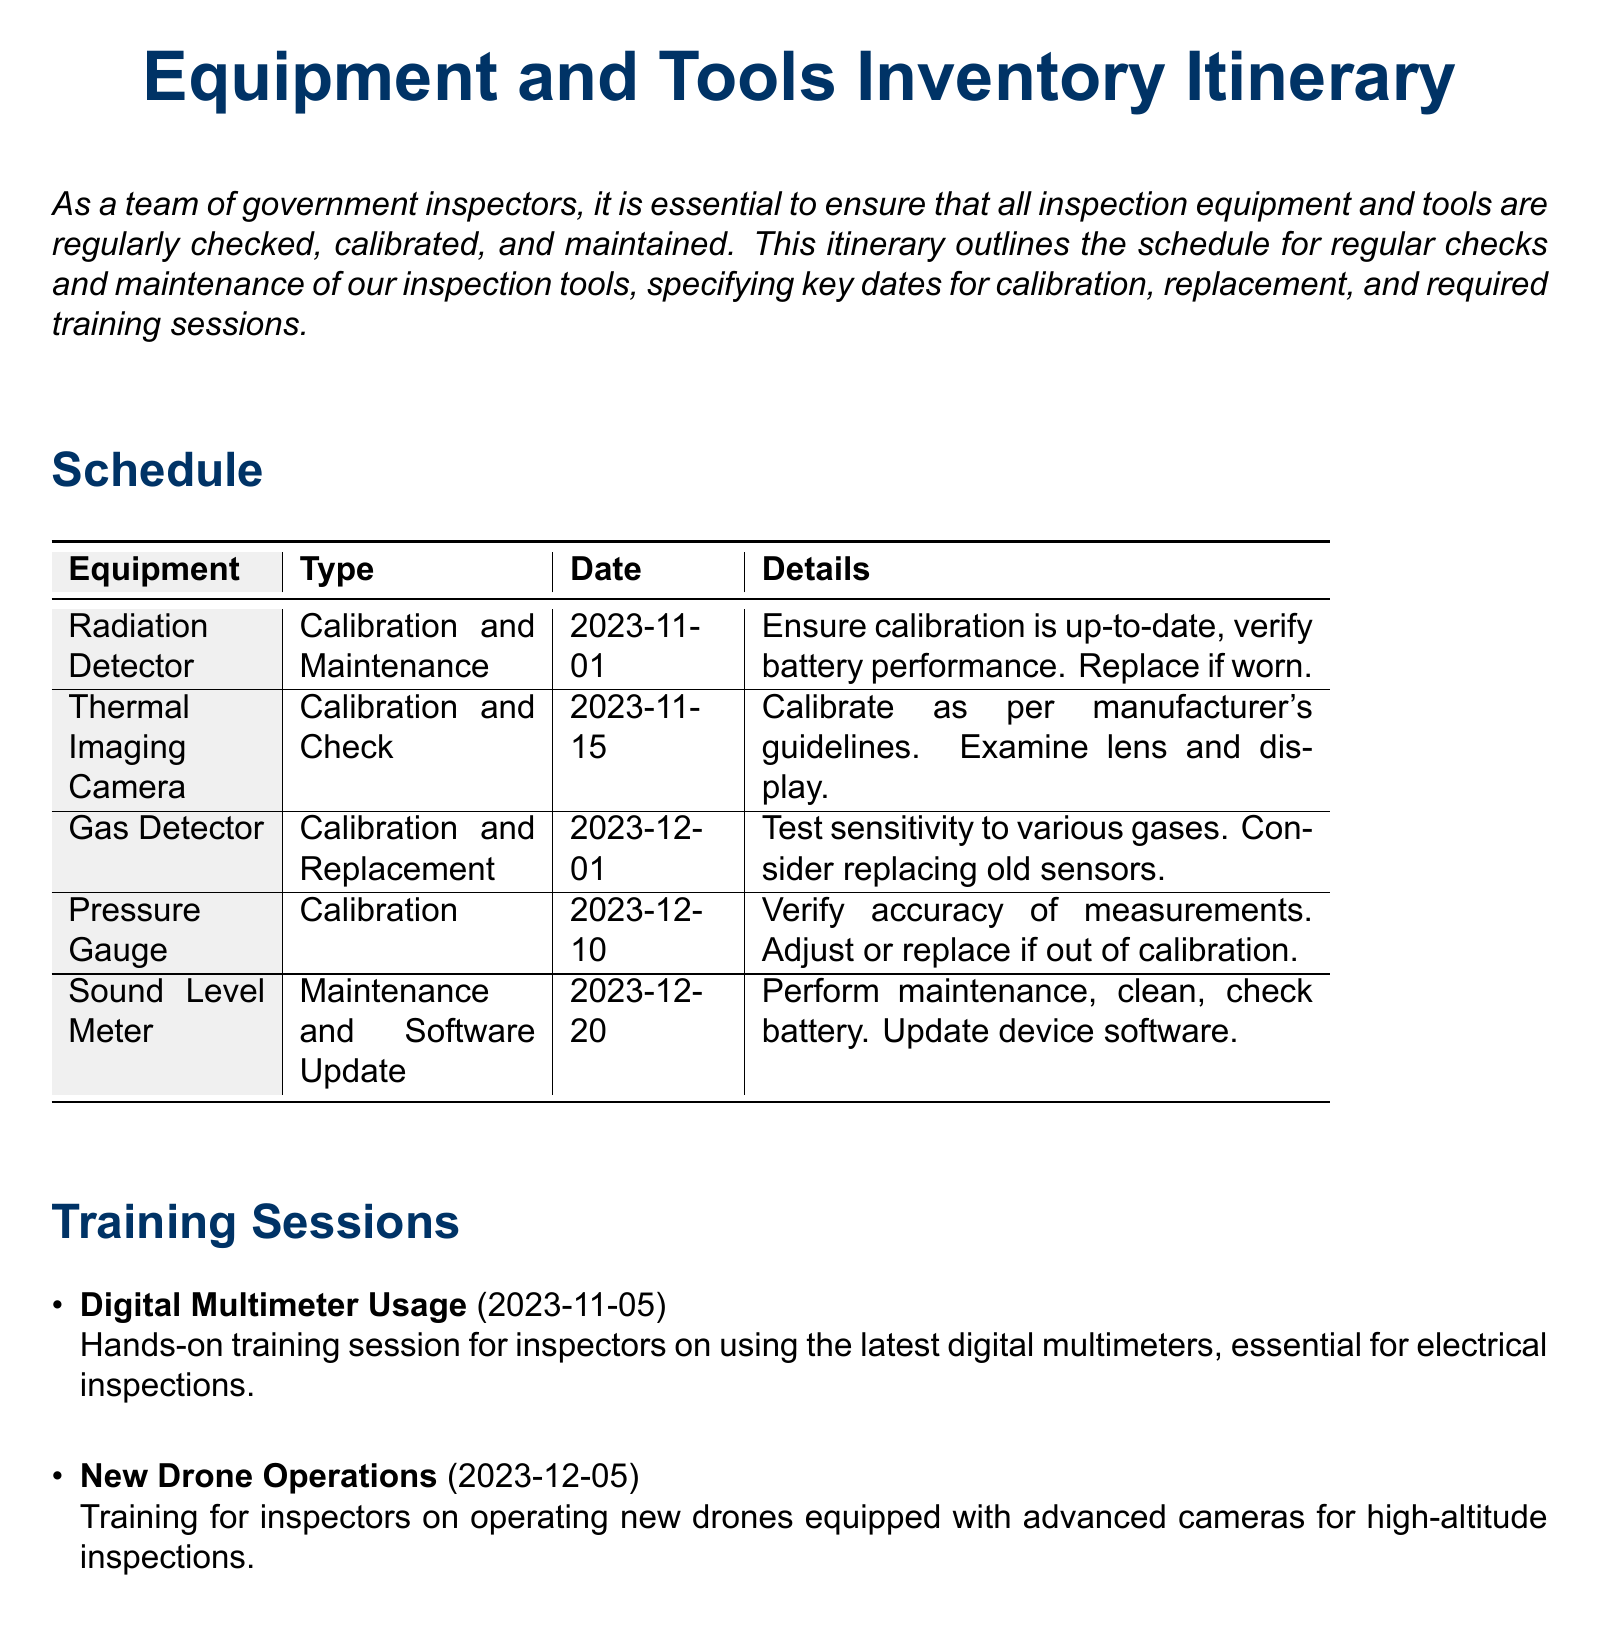What is the date for calibrating the Radiation Detector? The document specifies that the Radiation Detector is to be calibrated on November 1, 2023.
Answer: November 1, 2023 What type of maintenance is scheduled for the Thermal Imaging Camera? The Thermal Imaging Camera is scheduled for calibration and a check, as mentioned in the itinerary.
Answer: Calibration and Check What is the last maintenance activity listed in the schedule? The last maintenance activity in the schedule is for the Sound Level Meter on December 20, 2023.
Answer: December 20, 2023 How many training sessions are mentioned in the document? The document lists two training sessions for inspectors on new equipment usage.
Answer: Two What type of training session is scheduled for December 5, 2023? The session on December 5, 2023, is for New Drone Operations.
Answer: New Drone Operations What equipment requires sensitivity testing for various gases? The Gas Detector is the equipment that needs to undergo sensitivity testing for various gases.
Answer: Gas Detector Which month has the most scheduled equipment checks? December has three scheduled equipment checks, as outlined in the itinerary.
Answer: December What is the main focus of the Digital Multimeter training session? The Digital Multimeter training session focuses on hands-on usage for electrical inspections.
Answer: Hands-on usage for electrical inspections 